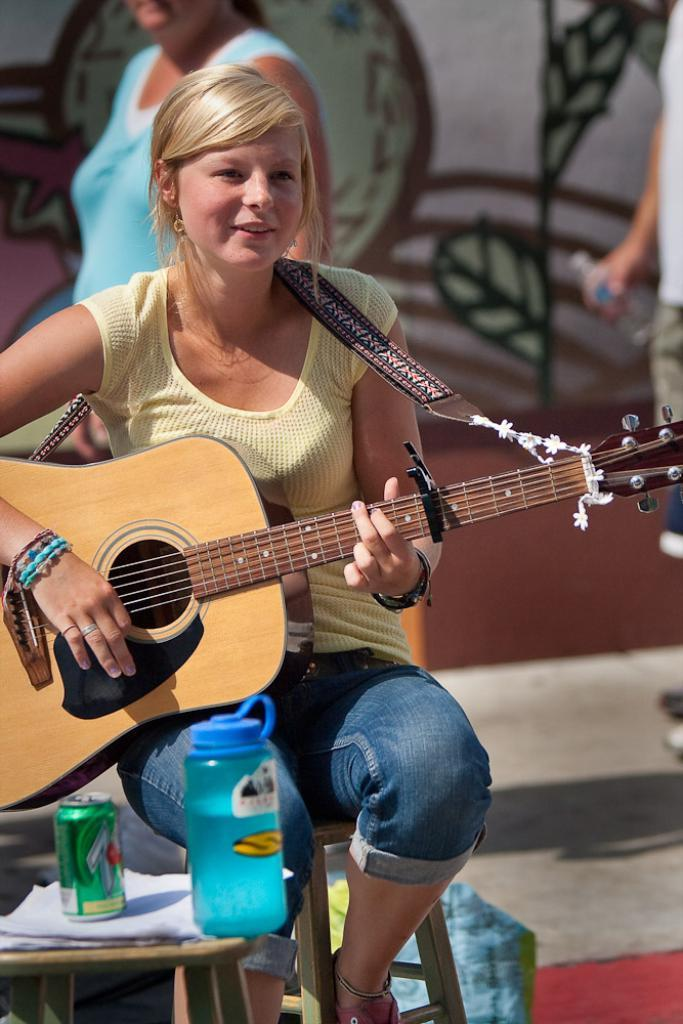What is the person in the image doing? The person is sitting on a stool and playing a guitar. What objects can be seen on the table in the image? There is a bottle, a tin, and papers on the table. Can you describe the background of the image? There are persons visible in the background and a wall in the background. How many spiders are crawling on the guitar in the image? There are no spiders visible in the image; the person is playing a guitar without any spiders present. What type of breath is required to play the guitar in the image? The image does not show the person playing the guitar or any specific breathing technique; it only shows the person sitting on a stool and playing the guitar. 